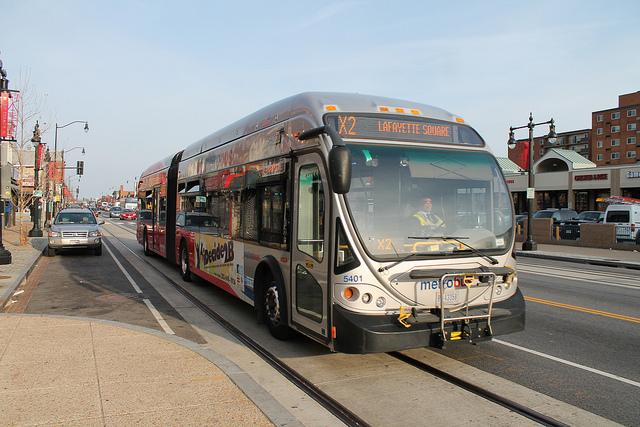Is the driver of the bus visible?
Concise answer only. Yes. Where is the bus?
Be succinct. Street. How many clouds are in the picture?
Keep it brief. 0. 